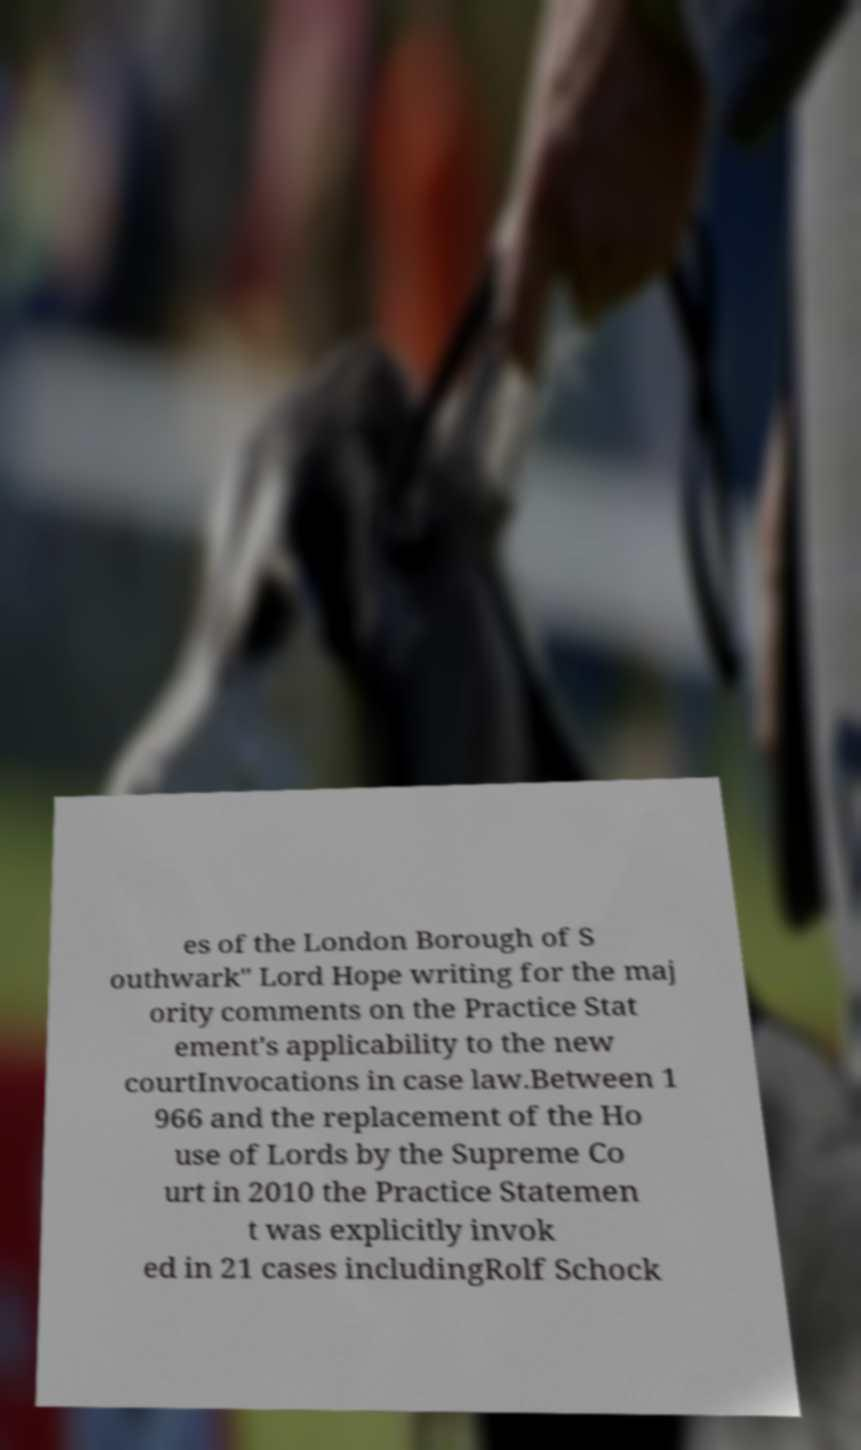I need the written content from this picture converted into text. Can you do that? es of the London Borough of S outhwark" Lord Hope writing for the maj ority comments on the Practice Stat ement's applicability to the new courtInvocations in case law.Between 1 966 and the replacement of the Ho use of Lords by the Supreme Co urt in 2010 the Practice Statemen t was explicitly invok ed in 21 cases includingRolf Schock 